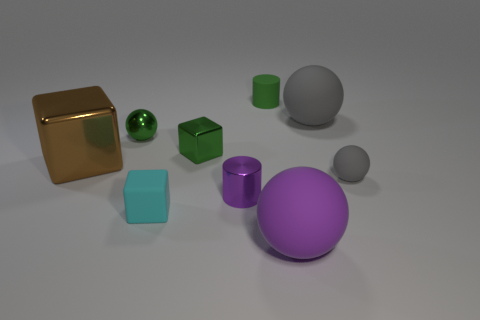What is the cylinder behind the purple metallic thing made of?
Make the answer very short. Rubber. What size is the brown cube?
Your answer should be compact. Large. Do the cube that is in front of the tiny gray matte ball and the purple object that is left of the large purple thing have the same size?
Your answer should be compact. Yes. What is the size of the other thing that is the same shape as the green matte thing?
Your response must be concise. Small. There is a shiny cylinder; is it the same size as the ball on the left side of the tiny green cylinder?
Your response must be concise. Yes. Is there a big sphere that is behind the cyan rubber thing that is on the left side of the big gray matte ball?
Your answer should be compact. Yes. What is the shape of the tiny metal object in front of the large brown block?
Offer a very short reply. Cylinder. What material is the large thing that is the same color as the tiny shiny cylinder?
Provide a succinct answer. Rubber. The ball that is left of the big matte sphere in front of the small purple thing is what color?
Ensure brevity in your answer.  Green. Does the purple shiny thing have the same size as the brown cube?
Your response must be concise. No. 